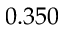<formula> <loc_0><loc_0><loc_500><loc_500>0 . 3 5 0</formula> 